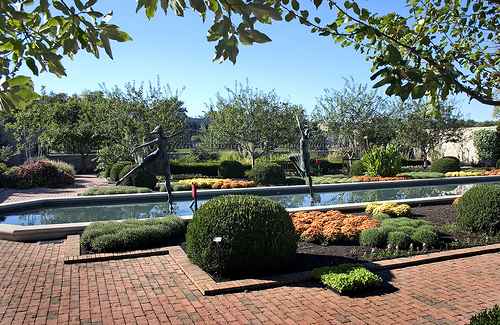<image>
Is the leaf on the bush? No. The leaf is not positioned on the bush. They may be near each other, but the leaf is not supported by or resting on top of the bush. 